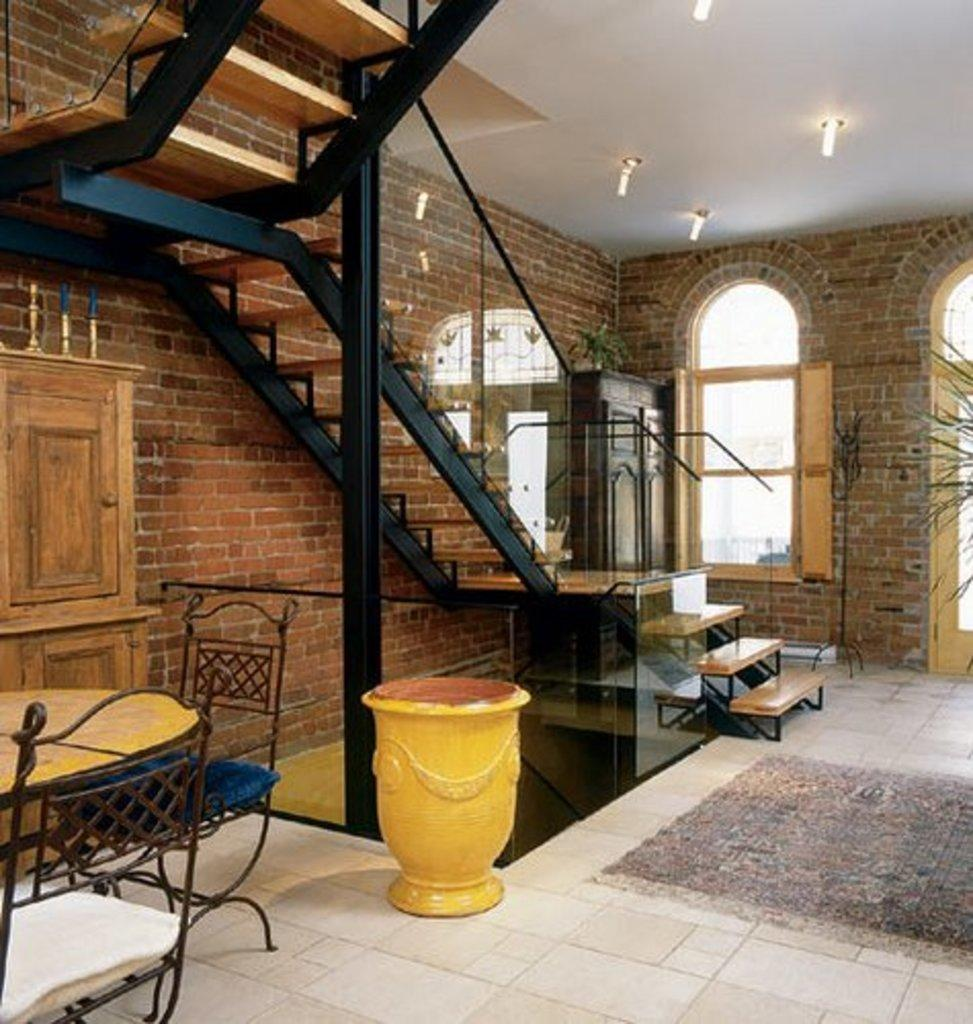What type of surface is visible in the image? There is a floor in the image. What architectural feature can be seen in the image? There is a staircase in the image. What material is used for the wall in the image? There is a wooden wall in the image. What type of furniture arrangement is present in the image? There is a table arrangement in the image. What type of window is visible in the image? There is a wooden window in the image. What can be seen on the roof in the image? There is a roof with a lighting arrangement in the image. What effect does the burst of sunlight have on the store in the image? There is no store present in the image, and therefore no burst of sunlight to have an effect on it. 